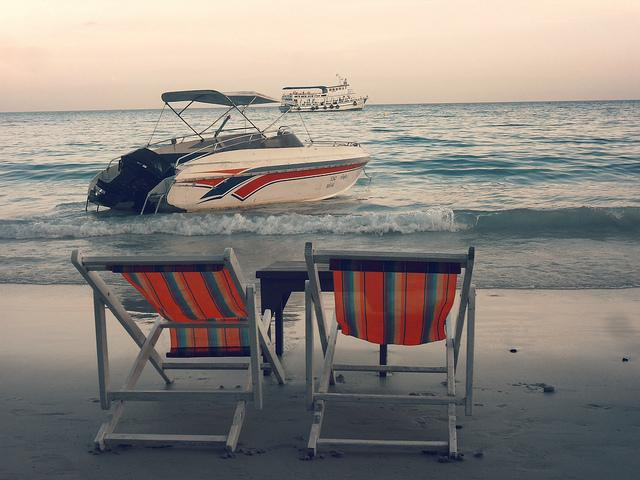What does the boat at the water's edge run on? Please explain your reasoning. rowing. The boat is of a size and weight that it would need to be powered by an engine to make it move. there is also a visible engine on the boat and if there is an engine on a boat it is likely the power source. 